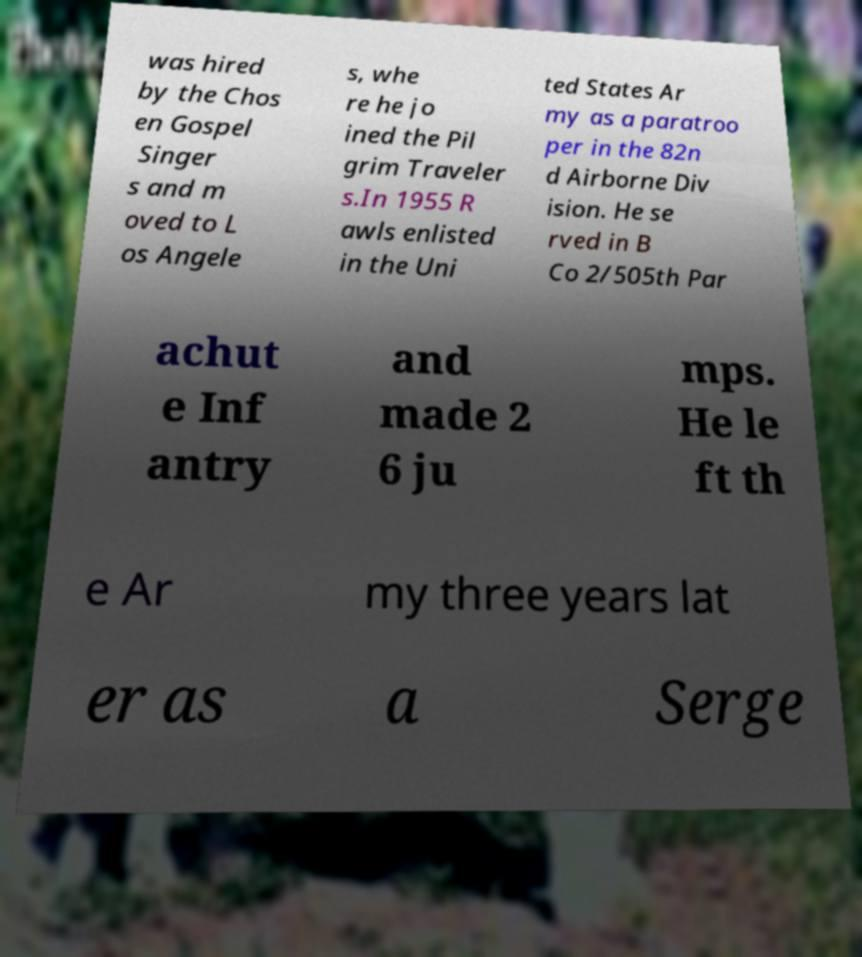Could you assist in decoding the text presented in this image and type it out clearly? was hired by the Chos en Gospel Singer s and m oved to L os Angele s, whe re he jo ined the Pil grim Traveler s.In 1955 R awls enlisted in the Uni ted States Ar my as a paratroo per in the 82n d Airborne Div ision. He se rved in B Co 2/505th Par achut e Inf antry and made 2 6 ju mps. He le ft th e Ar my three years lat er as a Serge 